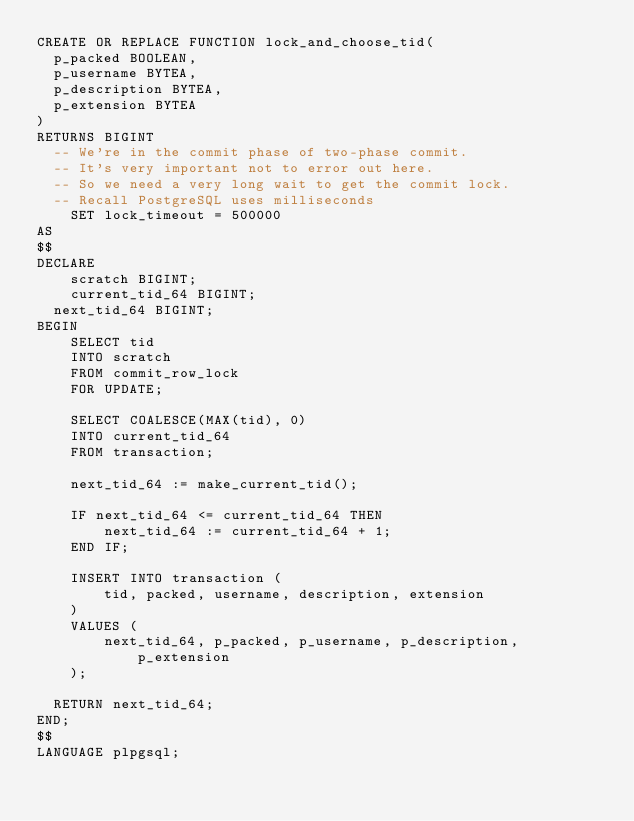<code> <loc_0><loc_0><loc_500><loc_500><_SQL_>CREATE OR REPLACE FUNCTION lock_and_choose_tid(
  p_packed BOOLEAN,
  p_username BYTEA,
  p_description BYTEA,
  p_extension BYTEA
)
RETURNS BIGINT
  -- We're in the commit phase of two-phase commit.
  -- It's very important not to error out here.
  -- So we need a very long wait to get the commit lock.
  -- Recall PostgreSQL uses milliseconds
    SET lock_timeout = 500000
AS
$$
DECLARE
    scratch BIGINT;
    current_tid_64 BIGINT;
  next_tid_64 BIGINT;
BEGIN
    SELECT tid
    INTO scratch
    FROM commit_row_lock
    FOR UPDATE;

    SELECT COALESCE(MAX(tid), 0)
    INTO current_tid_64
    FROM transaction;

    next_tid_64 := make_current_tid();

    IF next_tid_64 <= current_tid_64 THEN
        next_tid_64 := current_tid_64 + 1;
    END IF;

    INSERT INTO transaction (
        tid, packed, username, description, extension
    )
    VALUES (
        next_tid_64, p_packed, p_username, p_description, p_extension
    );

  RETURN next_tid_64;
END;
$$
LANGUAGE plpgsql;
</code> 